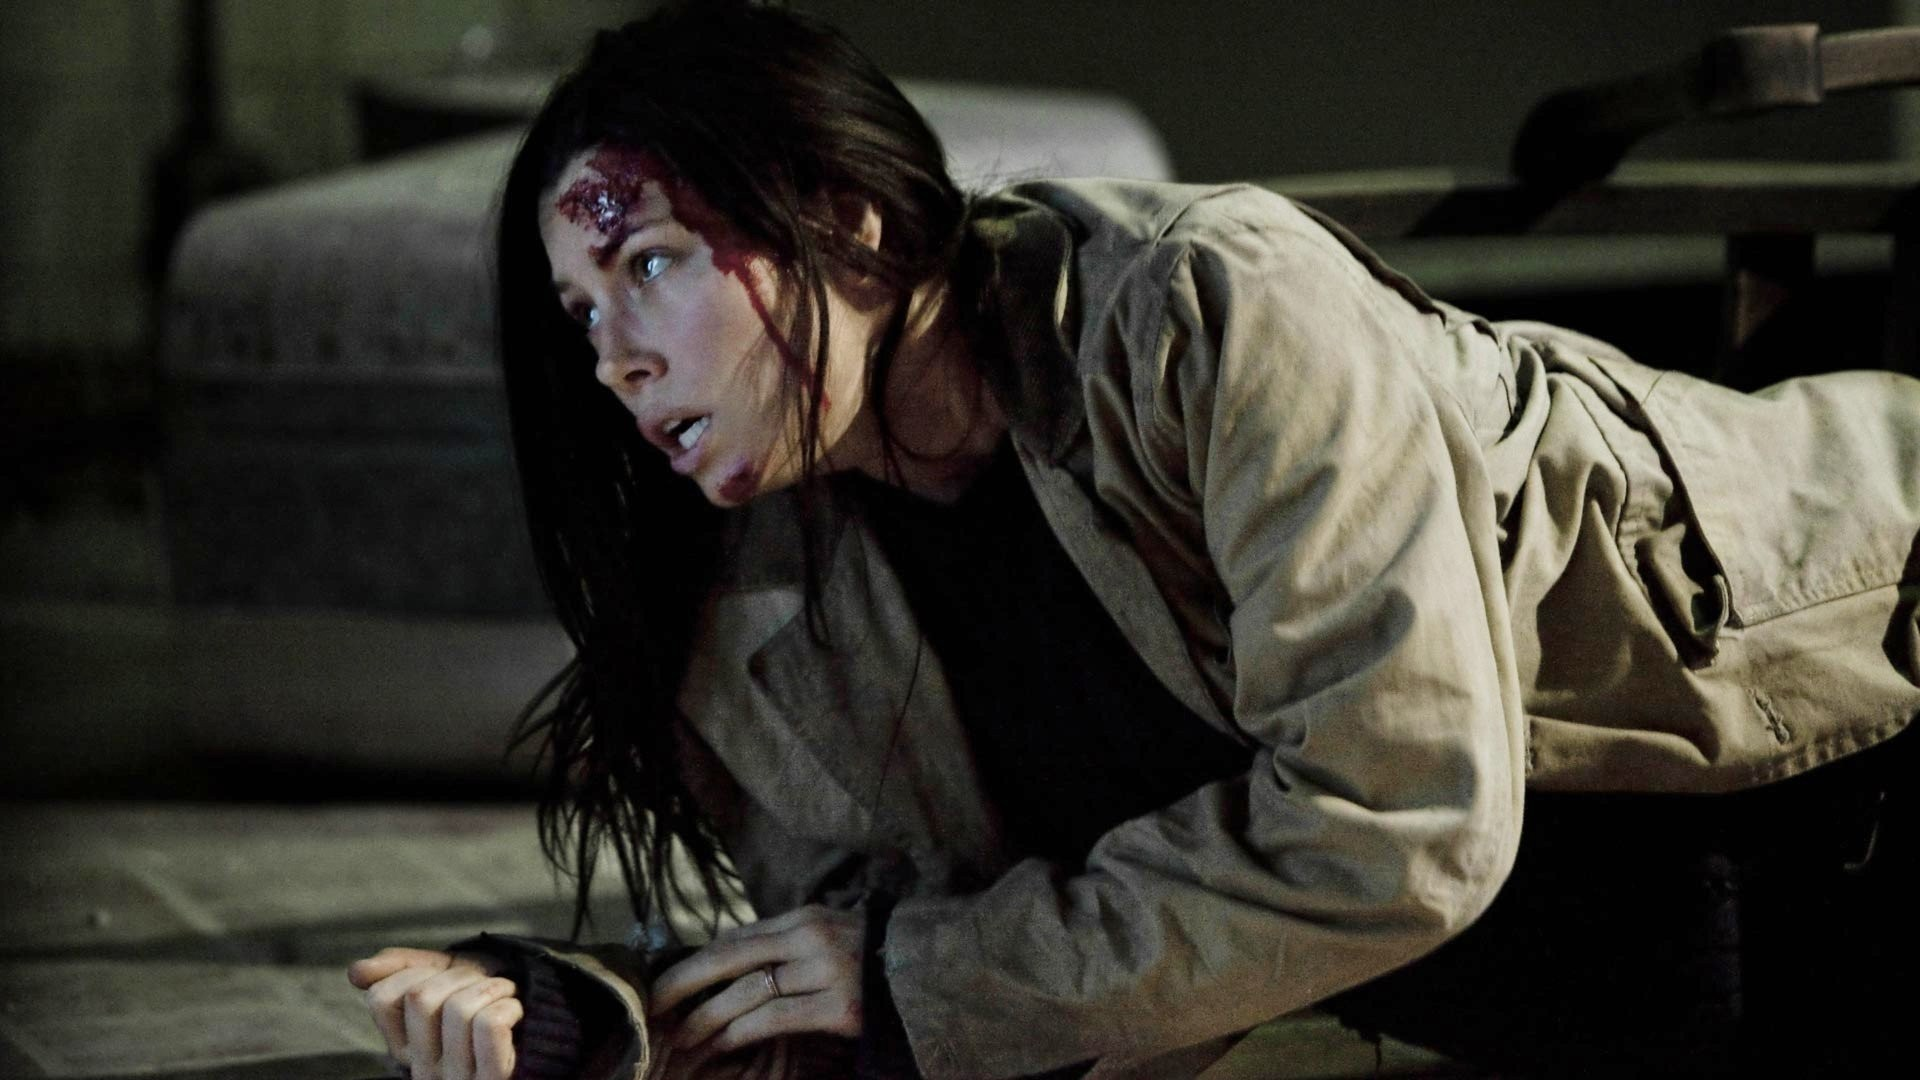What could be happening in this intense scene? In this intense scene, the woman might have been part of a conflict or trying to escape from a dangerous situation. She could be a character involved in a crime thriller or an action movie, crawling to safety after being injured or knocked down. The setting adds to the suspense, indicating that she might be hiding or running away from an antagonist. 